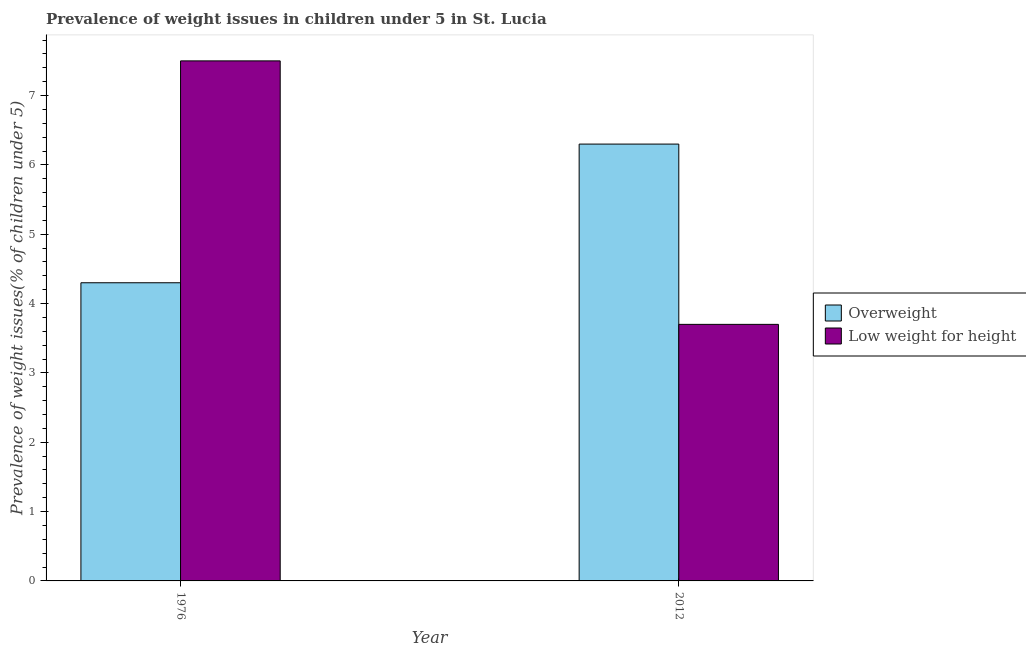How many groups of bars are there?
Make the answer very short. 2. Are the number of bars per tick equal to the number of legend labels?
Your answer should be very brief. Yes. How many bars are there on the 2nd tick from the left?
Provide a short and direct response. 2. How many bars are there on the 2nd tick from the right?
Keep it short and to the point. 2. What is the label of the 1st group of bars from the left?
Provide a succinct answer. 1976. In how many cases, is the number of bars for a given year not equal to the number of legend labels?
Provide a succinct answer. 0. What is the percentage of overweight children in 1976?
Provide a succinct answer. 4.3. Across all years, what is the maximum percentage of overweight children?
Your answer should be compact. 6.3. Across all years, what is the minimum percentage of overweight children?
Provide a short and direct response. 4.3. In which year was the percentage of overweight children maximum?
Your answer should be compact. 2012. In which year was the percentage of underweight children minimum?
Keep it short and to the point. 2012. What is the total percentage of underweight children in the graph?
Offer a very short reply. 11.2. What is the difference between the percentage of underweight children in 1976 and that in 2012?
Your response must be concise. 3.8. What is the difference between the percentage of overweight children in 1976 and the percentage of underweight children in 2012?
Provide a succinct answer. -2. What is the average percentage of underweight children per year?
Your answer should be very brief. 5.6. In the year 2012, what is the difference between the percentage of overweight children and percentage of underweight children?
Offer a very short reply. 0. In how many years, is the percentage of underweight children greater than 1.4 %?
Give a very brief answer. 2. What is the ratio of the percentage of overweight children in 1976 to that in 2012?
Your response must be concise. 0.68. What does the 1st bar from the left in 1976 represents?
Provide a succinct answer. Overweight. What does the 1st bar from the right in 2012 represents?
Make the answer very short. Low weight for height. How many bars are there?
Give a very brief answer. 4. What is the difference between two consecutive major ticks on the Y-axis?
Make the answer very short. 1. Are the values on the major ticks of Y-axis written in scientific E-notation?
Your answer should be compact. No. Where does the legend appear in the graph?
Your response must be concise. Center right. How many legend labels are there?
Keep it short and to the point. 2. What is the title of the graph?
Provide a succinct answer. Prevalence of weight issues in children under 5 in St. Lucia. What is the label or title of the X-axis?
Offer a very short reply. Year. What is the label or title of the Y-axis?
Ensure brevity in your answer.  Prevalence of weight issues(% of children under 5). What is the Prevalence of weight issues(% of children under 5) of Overweight in 1976?
Your answer should be very brief. 4.3. What is the Prevalence of weight issues(% of children under 5) of Overweight in 2012?
Provide a succinct answer. 6.3. What is the Prevalence of weight issues(% of children under 5) in Low weight for height in 2012?
Ensure brevity in your answer.  3.7. Across all years, what is the maximum Prevalence of weight issues(% of children under 5) of Overweight?
Your answer should be compact. 6.3. Across all years, what is the maximum Prevalence of weight issues(% of children under 5) in Low weight for height?
Your answer should be compact. 7.5. Across all years, what is the minimum Prevalence of weight issues(% of children under 5) in Overweight?
Provide a short and direct response. 4.3. Across all years, what is the minimum Prevalence of weight issues(% of children under 5) of Low weight for height?
Ensure brevity in your answer.  3.7. What is the total Prevalence of weight issues(% of children under 5) of Overweight in the graph?
Your answer should be very brief. 10.6. What is the difference between the Prevalence of weight issues(% of children under 5) of Overweight in 1976 and that in 2012?
Provide a succinct answer. -2. What is the difference between the Prevalence of weight issues(% of children under 5) in Low weight for height in 1976 and that in 2012?
Offer a very short reply. 3.8. What is the difference between the Prevalence of weight issues(% of children under 5) in Overweight in 1976 and the Prevalence of weight issues(% of children under 5) in Low weight for height in 2012?
Provide a succinct answer. 0.6. What is the average Prevalence of weight issues(% of children under 5) of Overweight per year?
Provide a succinct answer. 5.3. In the year 1976, what is the difference between the Prevalence of weight issues(% of children under 5) in Overweight and Prevalence of weight issues(% of children under 5) in Low weight for height?
Your answer should be very brief. -3.2. In the year 2012, what is the difference between the Prevalence of weight issues(% of children under 5) of Overweight and Prevalence of weight issues(% of children under 5) of Low weight for height?
Give a very brief answer. 2.6. What is the ratio of the Prevalence of weight issues(% of children under 5) of Overweight in 1976 to that in 2012?
Provide a succinct answer. 0.68. What is the ratio of the Prevalence of weight issues(% of children under 5) of Low weight for height in 1976 to that in 2012?
Your answer should be very brief. 2.03. What is the difference between the highest and the lowest Prevalence of weight issues(% of children under 5) of Overweight?
Your response must be concise. 2. What is the difference between the highest and the lowest Prevalence of weight issues(% of children under 5) in Low weight for height?
Offer a very short reply. 3.8. 